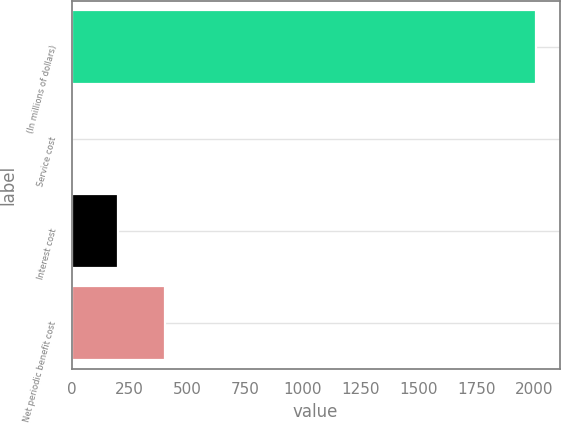Convert chart. <chart><loc_0><loc_0><loc_500><loc_500><bar_chart><fcel>(In millions of dollars)<fcel>Service cost<fcel>Interest cost<fcel>Net periodic benefit cost<nl><fcel>2009<fcel>1<fcel>201.8<fcel>402.6<nl></chart> 